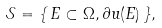<formula> <loc_0><loc_0><loc_500><loc_500>\mathcal { S } = \{ \, E \subset \Omega , \partial u ( E ) \, \} ,</formula> 